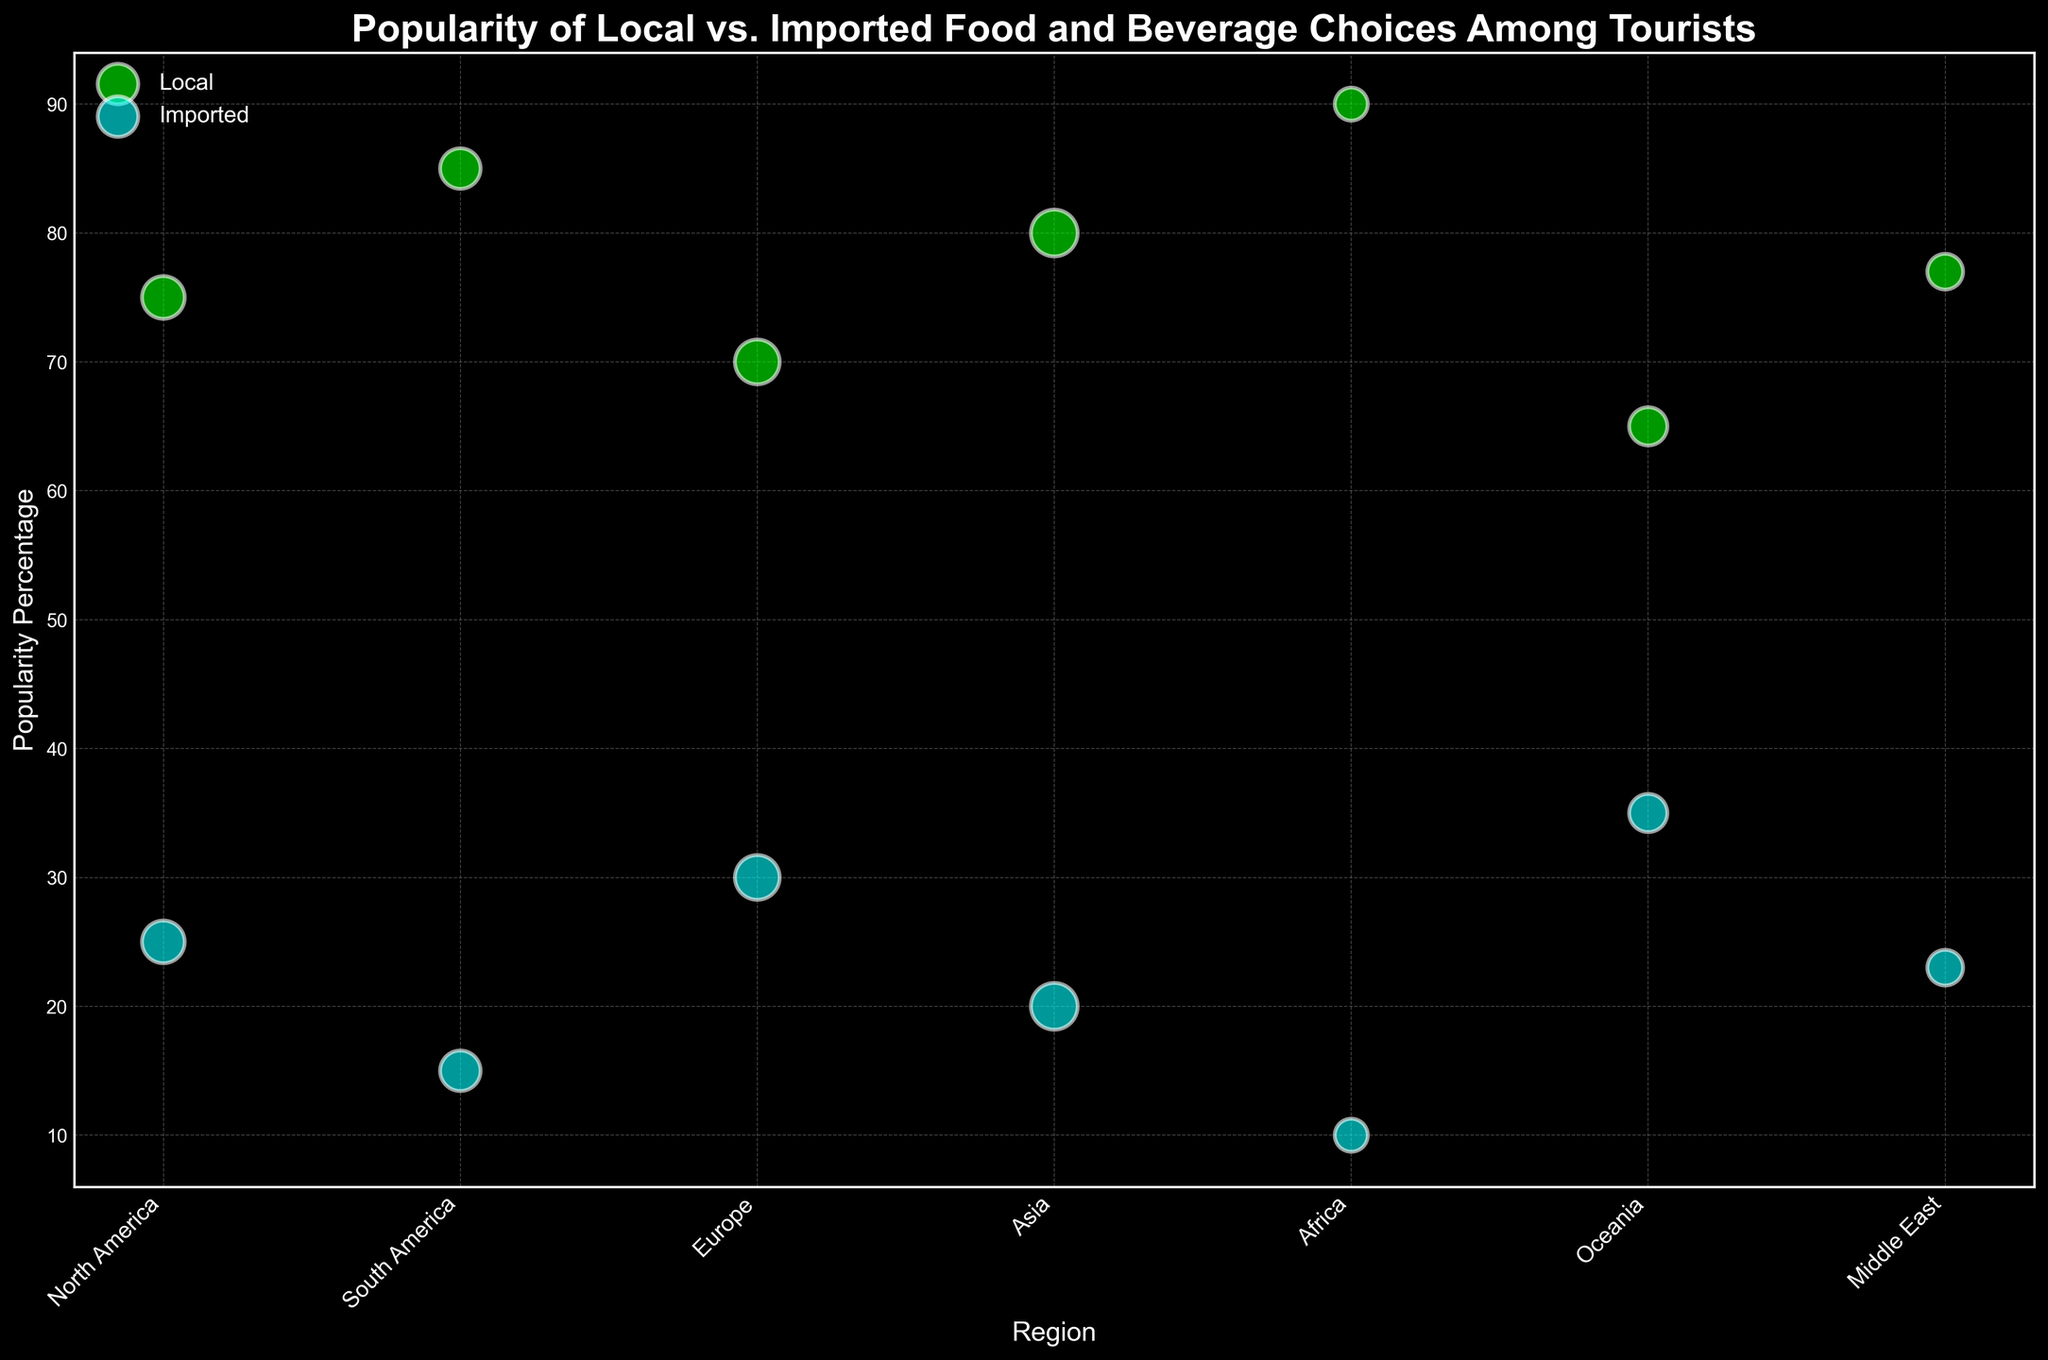What regions have a higher percentage of tourists preferring imported food over local food? Compare the percentages for imported food in each region against those for local food. Oceania is the only region where the popularity percentage for imported food (35%) is higher than several regions' local food popularity (65% for Oceania). All other regions have higher percentages for local food than imported food.
Answer: Oceania Which region has the widest gap in popularity percentage between local and imported food? Calculate the absolute difference between local and imported percentages for each region, then compare. Africa has the widest gap with 90% for local food and 10% for imported food, giving a difference of 80%.
Answer: Africa How does the popularity percentage of local food in Europe compare to Asia? Compare the percentages, noting that Europe has 70% and Asia has 80%.
Answer: Asia has a higher percentage In which regions do local food preferences surpass 75% popularity? Identify regions where the popularity percentage for local food is above 75%. Africa (90%), South America (85%), and Asia (80%) all surpass 75%.
Answer: Africa, South America, Asia What is the average popularity percentage for imported food across all regions? Sum up the percentages for imported food in all regions: 25% + 15% + 30% + 20% + 10% + 35% + 23% = 158%. Then divide by the number of regions (7). The average is 158/7.
Answer: Approximately 22.57% Which region has the highest respondent preference for local food? Identify the region with the highest data point for local food on the vertical axis. Africa has the highest with 90%.
Answer: Africa Among all regions, which has the smallest bubble for local food, indicating the fewest respondents? Check the size of the local food bubbles, with the smallest indicating the fewest respondents. Africa's bubble is smallest with 300 respondents.
Answer: Africa Compare the total number of respondents for local and imported food choices across all regions. Calculate the total number of respondents for local and imported food choices. Local: 500 + 450 + 550 + 600 + 300 + 400 + 350 = 3150. Imported: 500 + 450 + 550 + 600 + 300 + 400 + 350 = 3150. Both categories have the same total.
Answer: Equal 